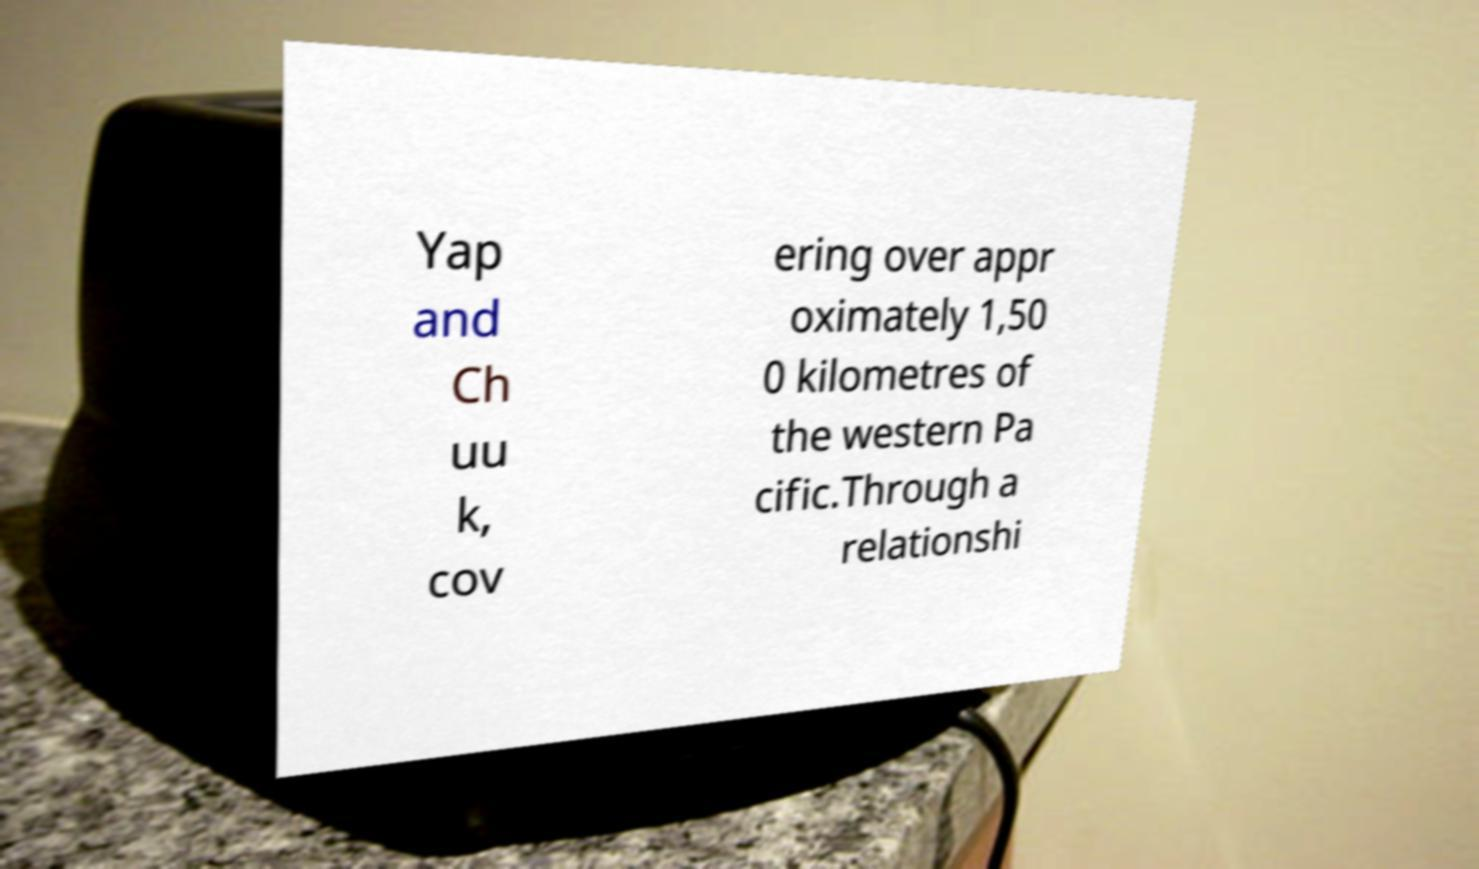Could you assist in decoding the text presented in this image and type it out clearly? Yap and Ch uu k, cov ering over appr oximately 1,50 0 kilometres of the western Pa cific.Through a relationshi 